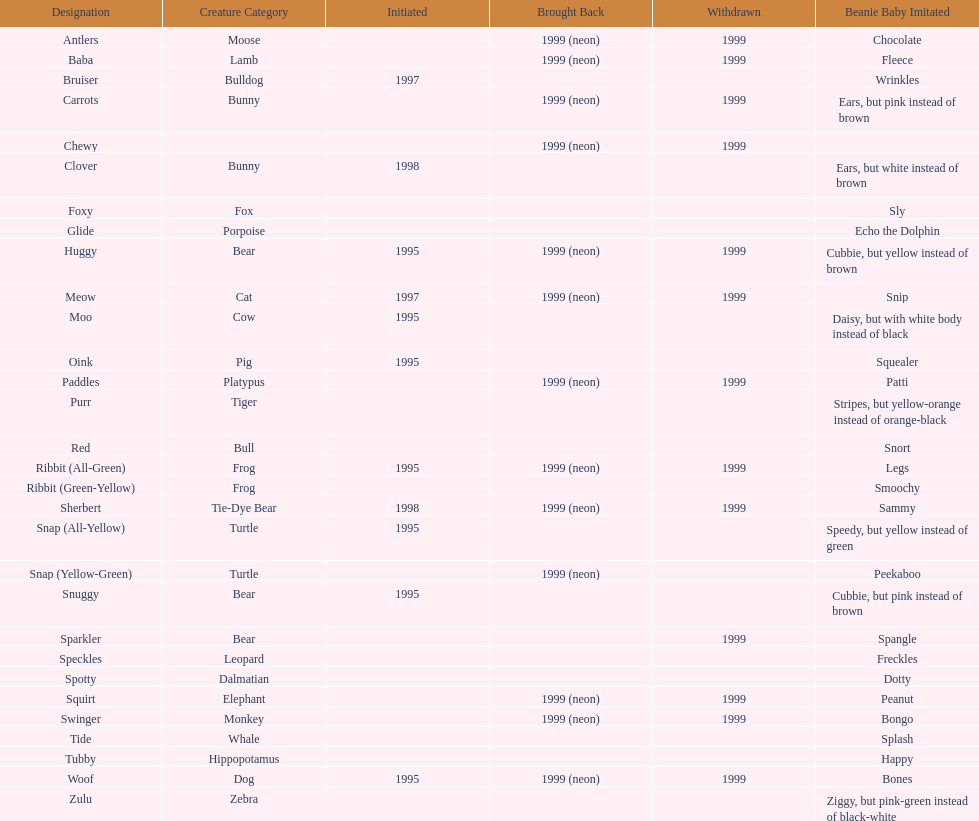How long was woof the dog sold before it was retired? 4 years. 